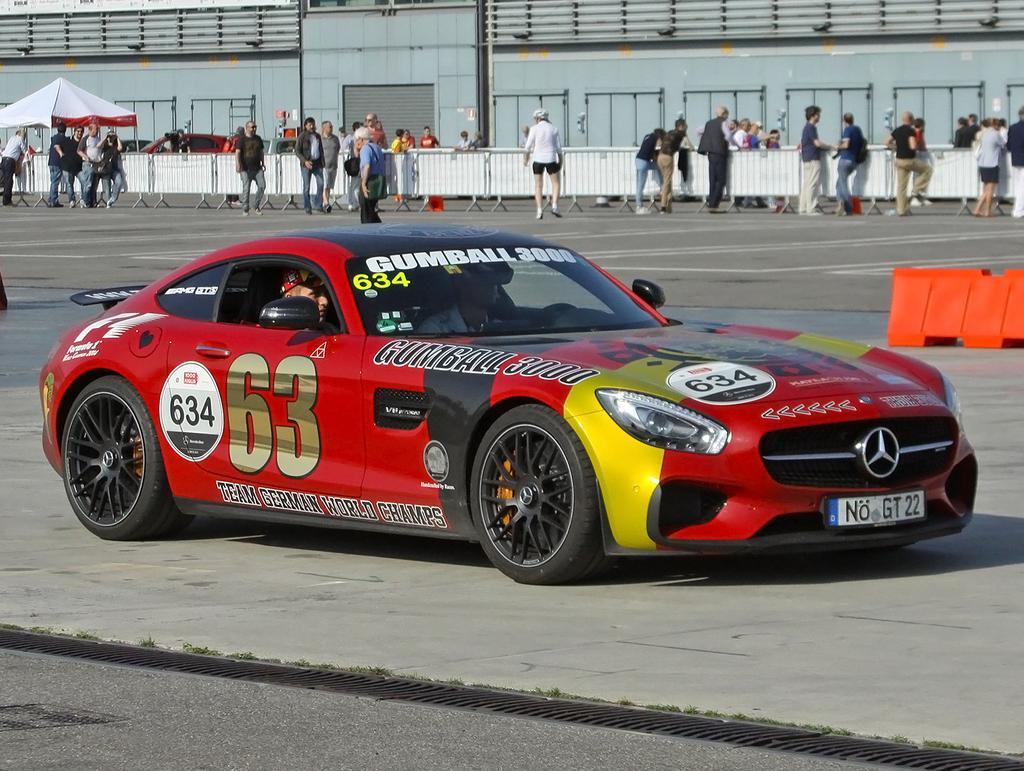Could you give a brief overview of what you see in this image? In the center of the image we can see a racing car on the road. In the background there are people. On the left we can see a tent and there is a building. We can see a fence. On the left there is a traffic cone. 